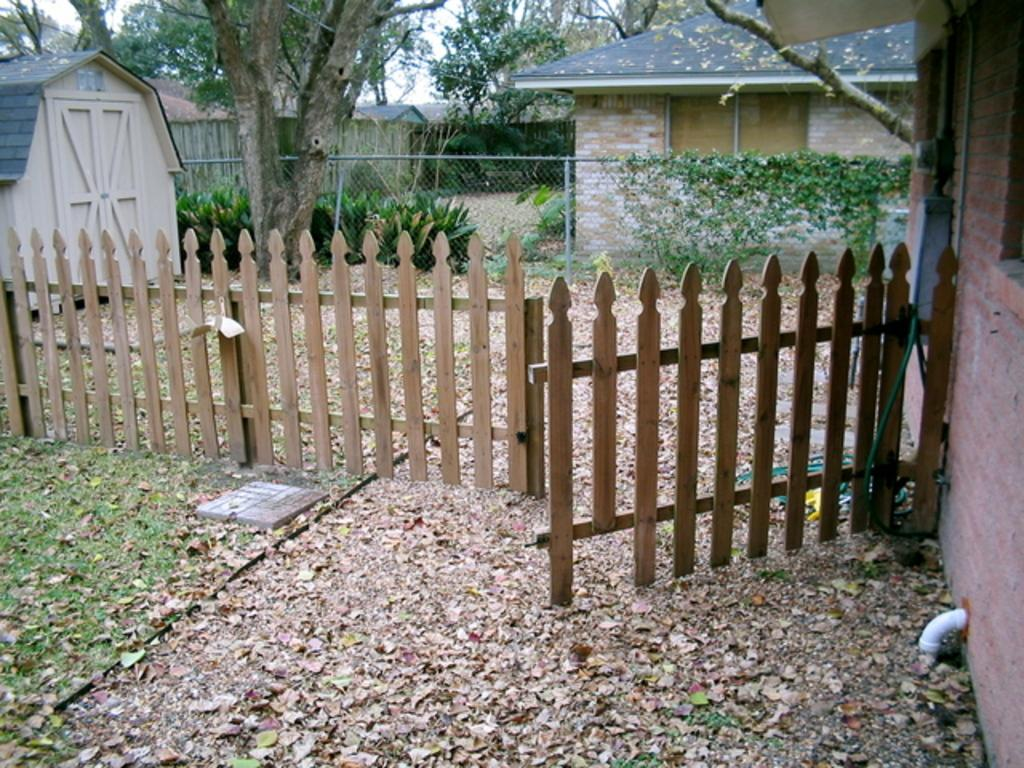What is the main structure visible in the image? There is a gate in the image. What can be seen in the distance behind the gate? There are houses and trees in the background of the image. What type of barrier is present in front of the house? Fencing is present in front of the house. What type of cloth is hanging from the swing in the image? There is no swing or cloth present in the image. 